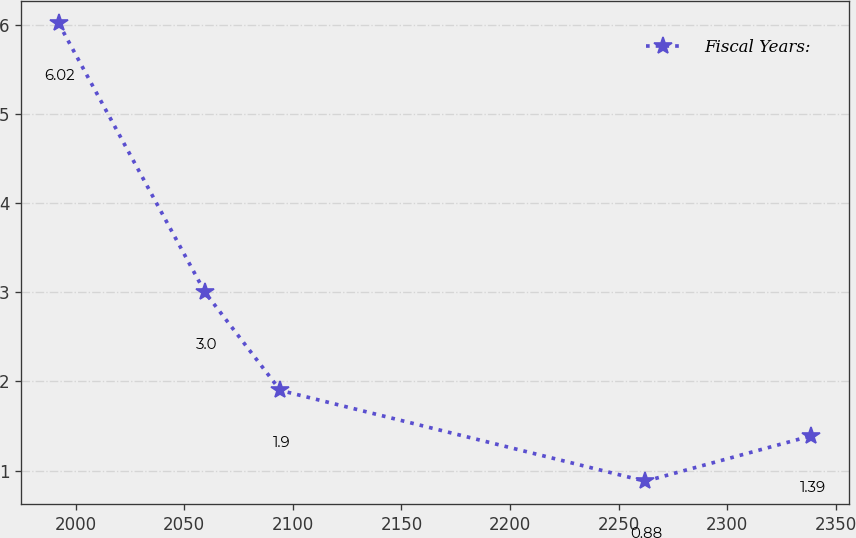<chart> <loc_0><loc_0><loc_500><loc_500><line_chart><ecel><fcel>Fiscal Years:<nl><fcel>1992.27<fcel>6.02<nl><fcel>2059.61<fcel>3<nl><fcel>2094.25<fcel>1.9<nl><fcel>2262.22<fcel>0.88<nl><fcel>2338.69<fcel>1.39<nl></chart> 